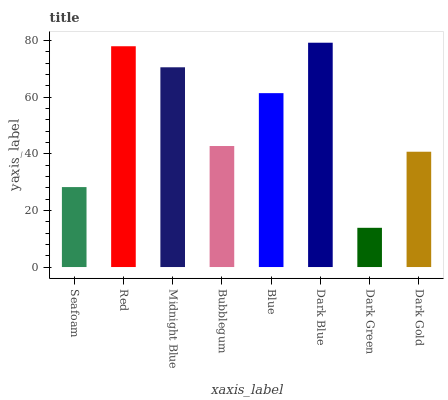Is Dark Green the minimum?
Answer yes or no. Yes. Is Dark Blue the maximum?
Answer yes or no. Yes. Is Red the minimum?
Answer yes or no. No. Is Red the maximum?
Answer yes or no. No. Is Red greater than Seafoam?
Answer yes or no. Yes. Is Seafoam less than Red?
Answer yes or no. Yes. Is Seafoam greater than Red?
Answer yes or no. No. Is Red less than Seafoam?
Answer yes or no. No. Is Blue the high median?
Answer yes or no. Yes. Is Bubblegum the low median?
Answer yes or no. Yes. Is Dark Green the high median?
Answer yes or no. No. Is Seafoam the low median?
Answer yes or no. No. 